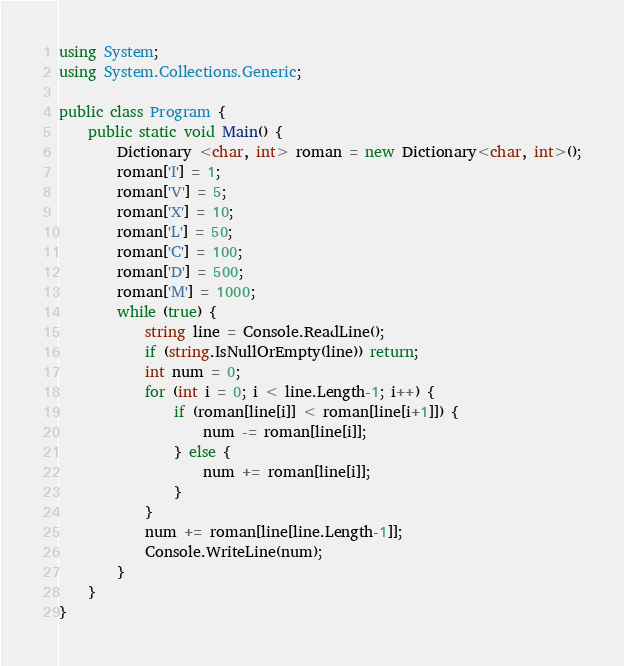Convert code to text. <code><loc_0><loc_0><loc_500><loc_500><_C#_>using System;
using System.Collections.Generic;

public class Program {
    public static void Main() {
        Dictionary <char, int> roman = new Dictionary<char, int>();
        roman['I'] = 1;
        roman['V'] = 5;
        roman['X'] = 10;
        roman['L'] = 50;
        roman['C'] = 100;
        roman['D'] = 500;
        roman['M'] = 1000;
        while (true) {
            string line = Console.ReadLine();
            if (string.IsNullOrEmpty(line)) return;
            int num = 0;
            for (int i = 0; i < line.Length-1; i++) {
                if (roman[line[i]] < roman[line[i+1]]) {
                    num -= roman[line[i]];
                } else {
                    num += roman[line[i]];
                }
            }
            num += roman[line[line.Length-1]];
            Console.WriteLine(num);
        }
    }
}</code> 